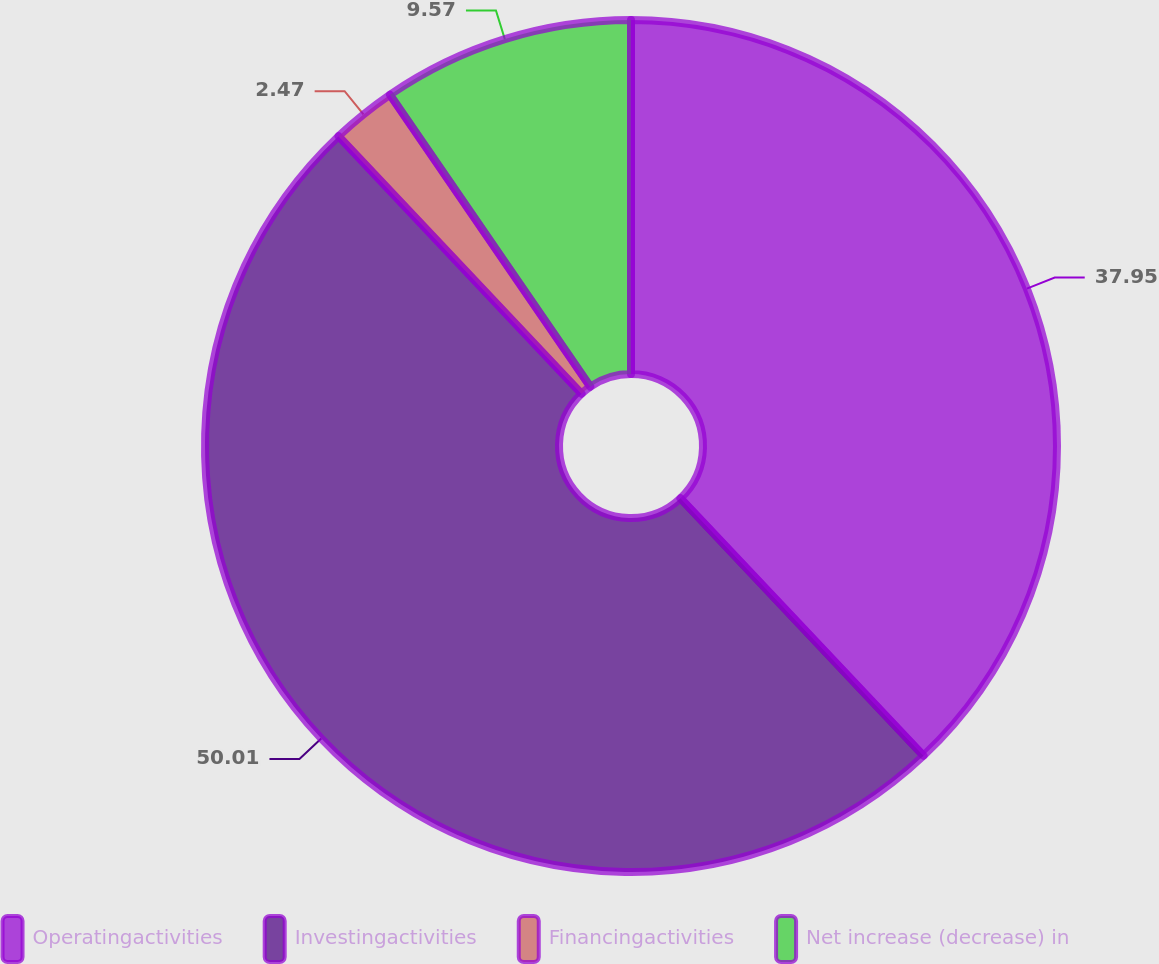Convert chart to OTSL. <chart><loc_0><loc_0><loc_500><loc_500><pie_chart><fcel>Operatingactivities<fcel>Investingactivities<fcel>Financingactivities<fcel>Net increase (decrease) in<nl><fcel>37.95%<fcel>50.0%<fcel>2.47%<fcel>9.57%<nl></chart> 